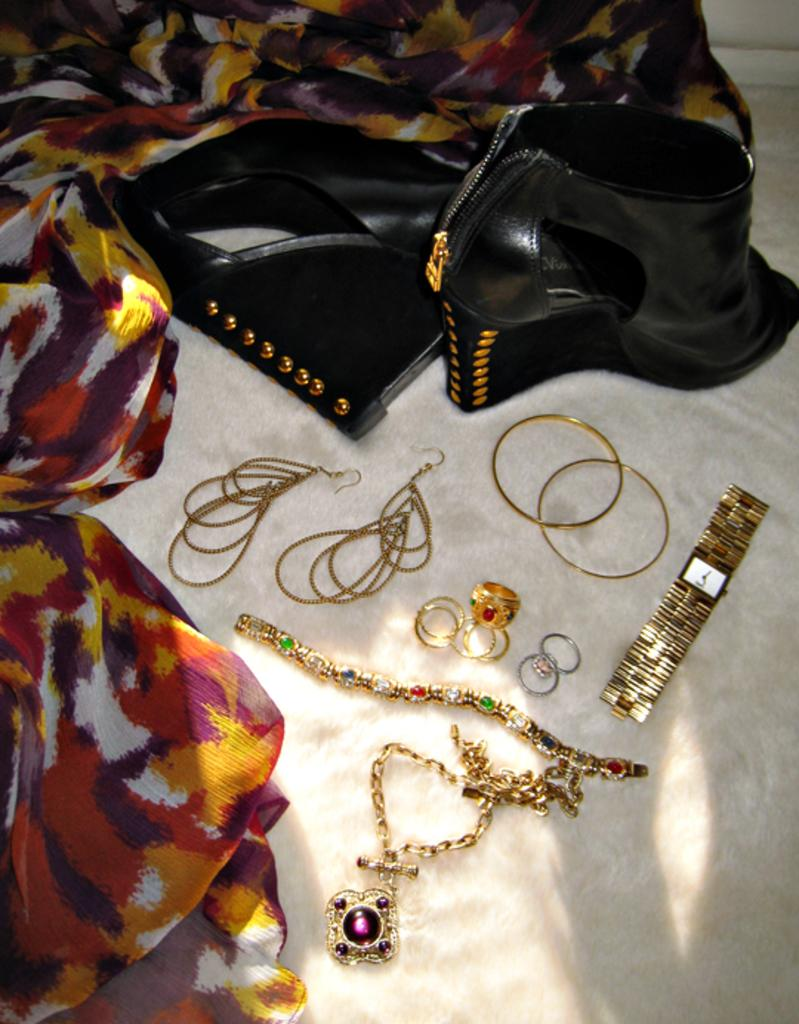Where was the image taken? The image was taken indoors. What is located at the bottom of the image? There is a towel at the bottom of the image. What items are placed on the towel? There is a scarf, high heels, earrings, bangles, a watch, rings, a chain, and a bracelet on the towel. How many children are playing with the skate in the image? There are no children or skate present in the image. What type of care is being provided to the items on the towel? The image does not show any care being provided to the items on the towel; it simply displays them arranged on the towel. 